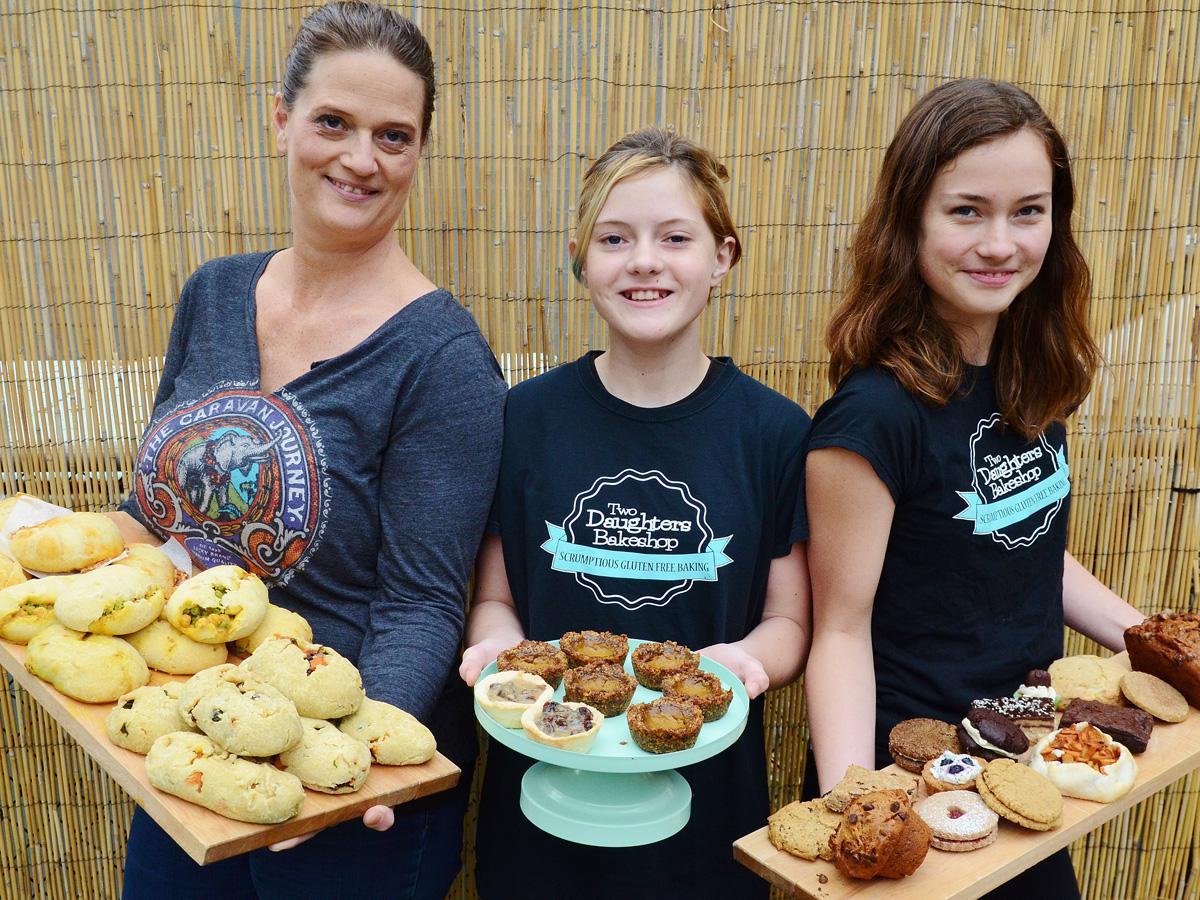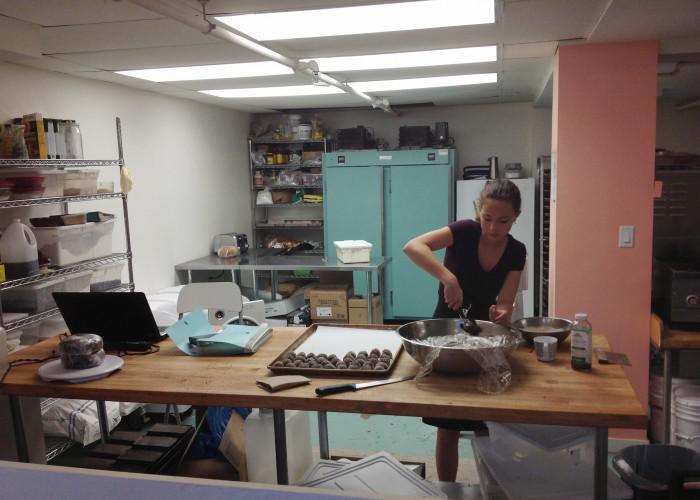The first image is the image on the left, the second image is the image on the right. Considering the images on both sides, is "The image on the left shows desserts in the foreground and exactly three people." valid? Answer yes or no. Yes. The first image is the image on the left, the second image is the image on the right. Assess this claim about the two images: "One image includes a girl at least on the right of an adult woman, and they are standing behind a rectangle of glass.". Correct or not? Answer yes or no. No. 